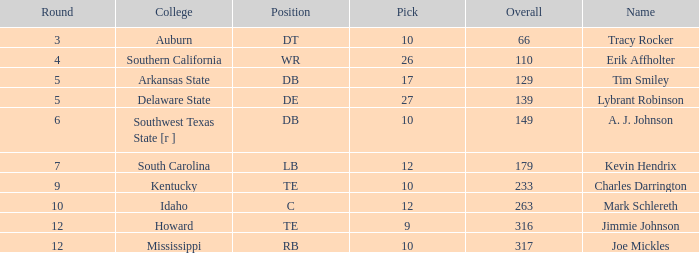What is the sum of Overall, when College is "Arkansas State", and when Pick is less than 17? None. 